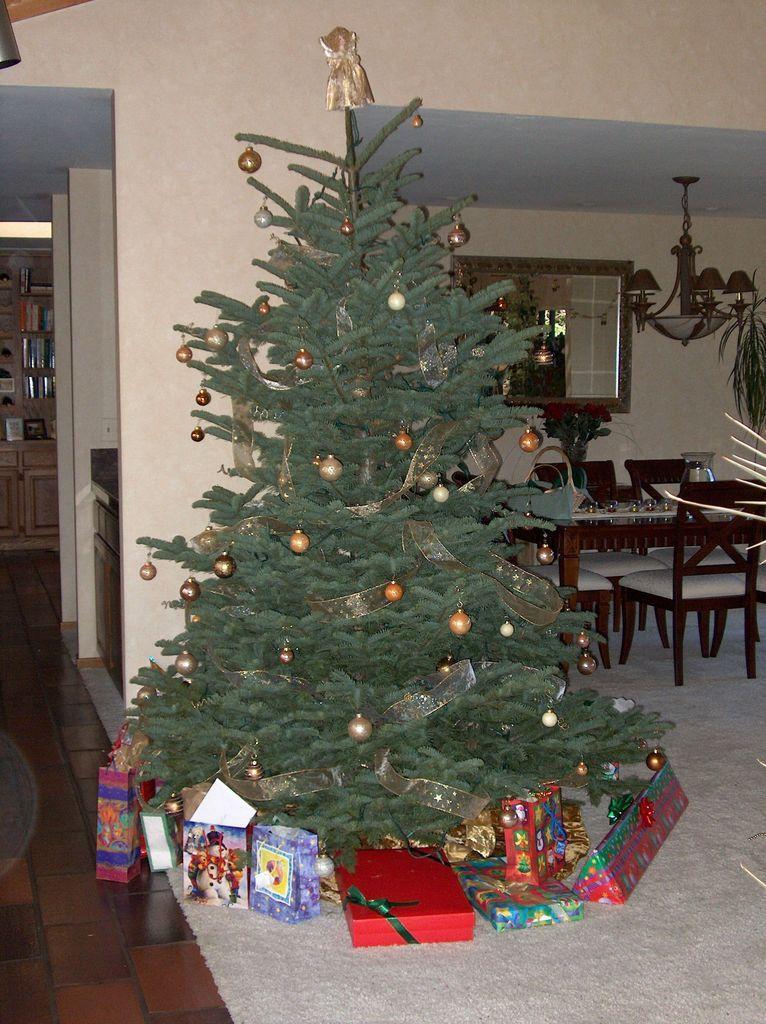Describe this image in one or two sentences. I can see a Christmas tree, which is decorated with the balls. These are the gifts, which are placed on the floor. I can see a table and the chairs. This looks like a flower vase with the flowers in it. Here is a lamp hanging. I think this is a carpet on the floor. These are the pillars. In the background, I can see few objects placed in the rack. 